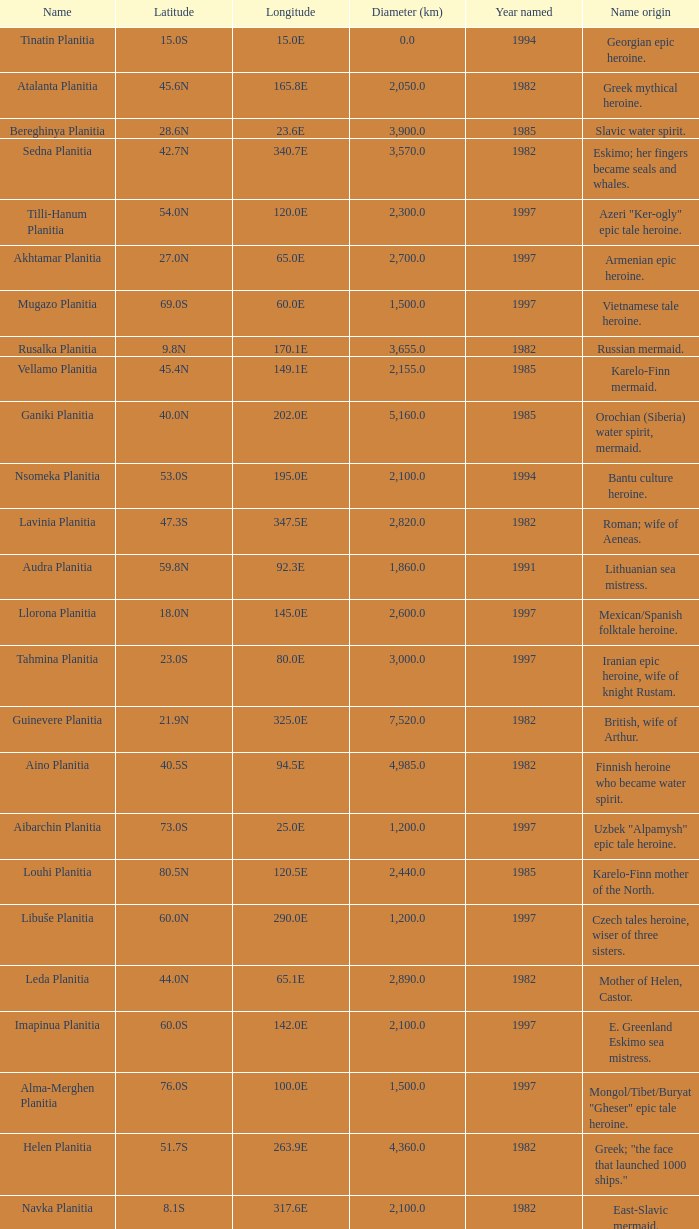What is the diameter (km) of feature of latitude 40.5s 4985.0. 